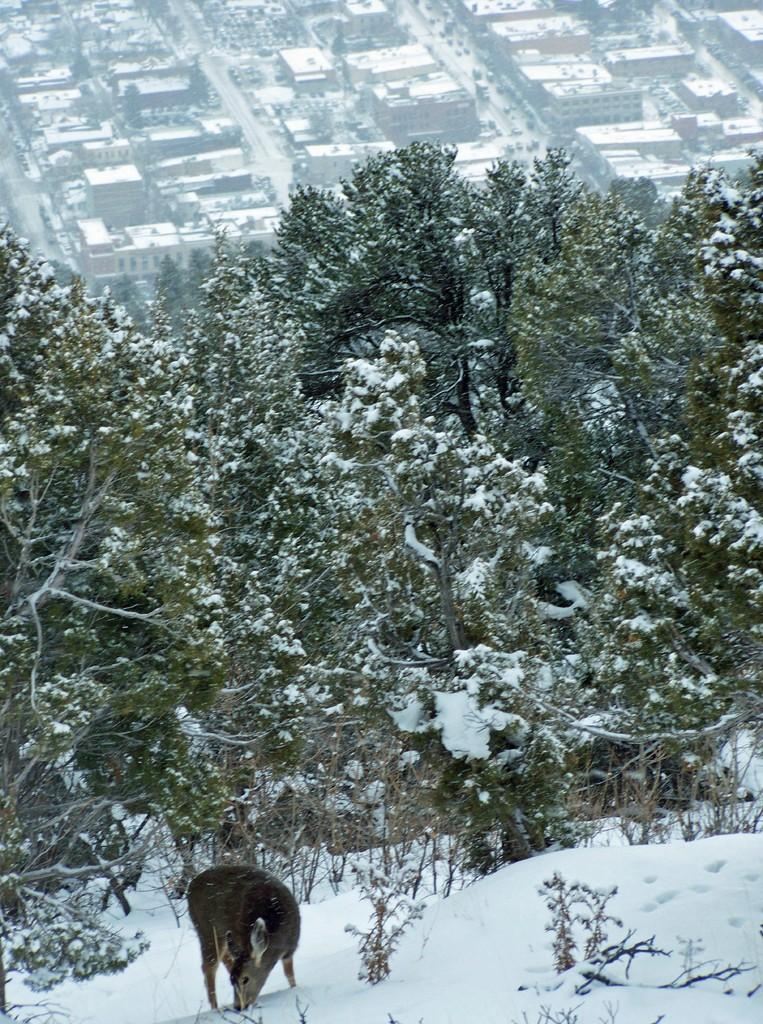What type of animal is present in the image? There is an animal in the image, but its specific type cannot be determined from the provided facts. What is the condition of the trees in the background of the image? The trees in the background of the image are covered with snow. What is the color of the trees in the image? The trees are in green color. What else can be seen in the background of the image? There are buildings visible in the background of the image. What type of veil is draped over the animal in the image? There is no veil present in the image; it only features an animal, trees covered with snow, green trees, and buildings in the background. 